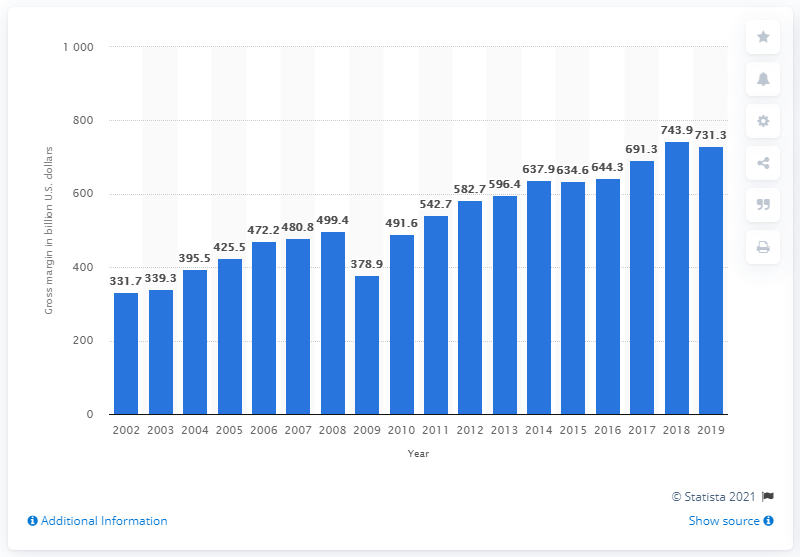Draw attention to some important aspects in this diagram. In 2019, the gross margin on durable goods in U.S. wholesale was 731.3%. 